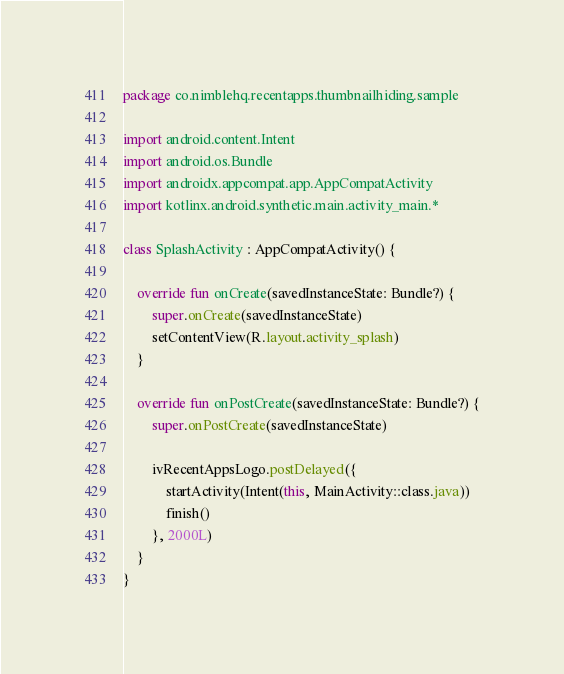<code> <loc_0><loc_0><loc_500><loc_500><_Kotlin_>package co.nimblehq.recentapps.thumbnailhiding.sample

import android.content.Intent
import android.os.Bundle
import androidx.appcompat.app.AppCompatActivity
import kotlinx.android.synthetic.main.activity_main.*

class SplashActivity : AppCompatActivity() {

    override fun onCreate(savedInstanceState: Bundle?) {
        super.onCreate(savedInstanceState)
        setContentView(R.layout.activity_splash)
    }

    override fun onPostCreate(savedInstanceState: Bundle?) {
        super.onPostCreate(savedInstanceState)

        ivRecentAppsLogo.postDelayed({
            startActivity(Intent(this, MainActivity::class.java))
            finish()
        }, 2000L)
    }
}
</code> 